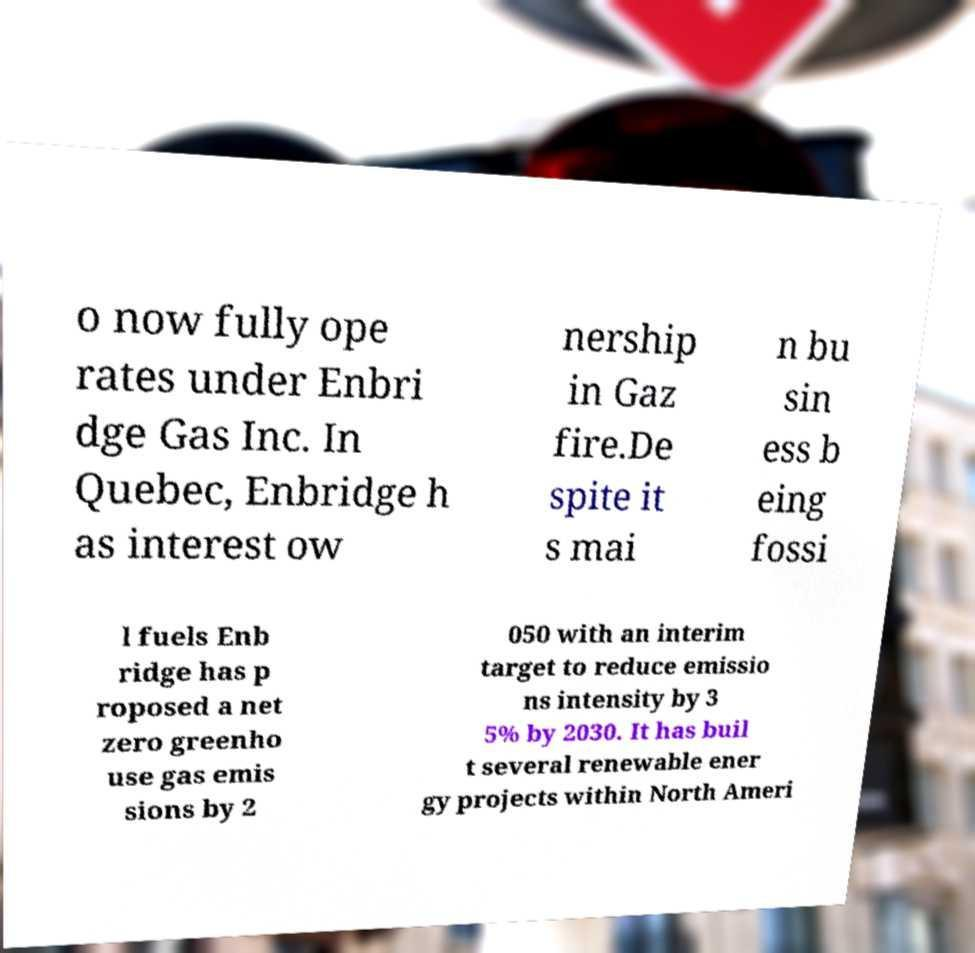Please identify and transcribe the text found in this image. o now fully ope rates under Enbri dge Gas Inc. In Quebec, Enbridge h as interest ow nership in Gaz fire.De spite it s mai n bu sin ess b eing fossi l fuels Enb ridge has p roposed a net zero greenho use gas emis sions by 2 050 with an interim target to reduce emissio ns intensity by 3 5% by 2030. It has buil t several renewable ener gy projects within North Ameri 